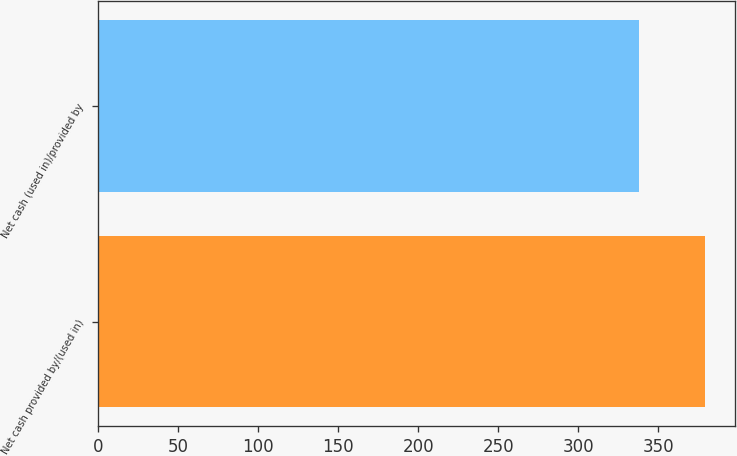Convert chart to OTSL. <chart><loc_0><loc_0><loc_500><loc_500><bar_chart><fcel>Net cash provided by/(used in)<fcel>Net cash (used in)/provided by<nl><fcel>379.2<fcel>337.8<nl></chart> 